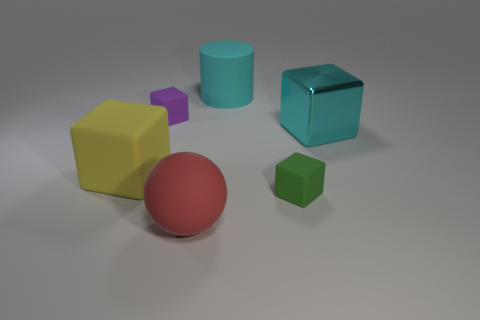How many objects are on the right side of the big red sphere and in front of the big yellow rubber block?
Ensure brevity in your answer.  1. What color is the small rubber block behind the small rubber cube that is in front of the large cyan thing in front of the tiny purple rubber cube?
Keep it short and to the point. Purple. How many other things are there of the same shape as the large cyan rubber thing?
Keep it short and to the point. 0. There is a rubber block that is to the right of the tiny purple matte cube; is there a red object behind it?
Your answer should be very brief. No. What number of metal objects are either large red things or big things?
Provide a succinct answer. 1. There is a big object that is on the left side of the cyan matte cylinder and on the right side of the tiny purple cube; what is its material?
Offer a terse response. Rubber. Are there any big things that are to the left of the rubber cube that is in front of the big yellow object that is behind the big matte sphere?
Your response must be concise. Yes. Is there any other thing that has the same material as the yellow block?
Your response must be concise. Yes. There is a purple thing that is the same material as the yellow block; what is its shape?
Your answer should be very brief. Cube. Is the number of red balls left of the red rubber object less than the number of cylinders that are on the right side of the green matte block?
Offer a very short reply. No. 